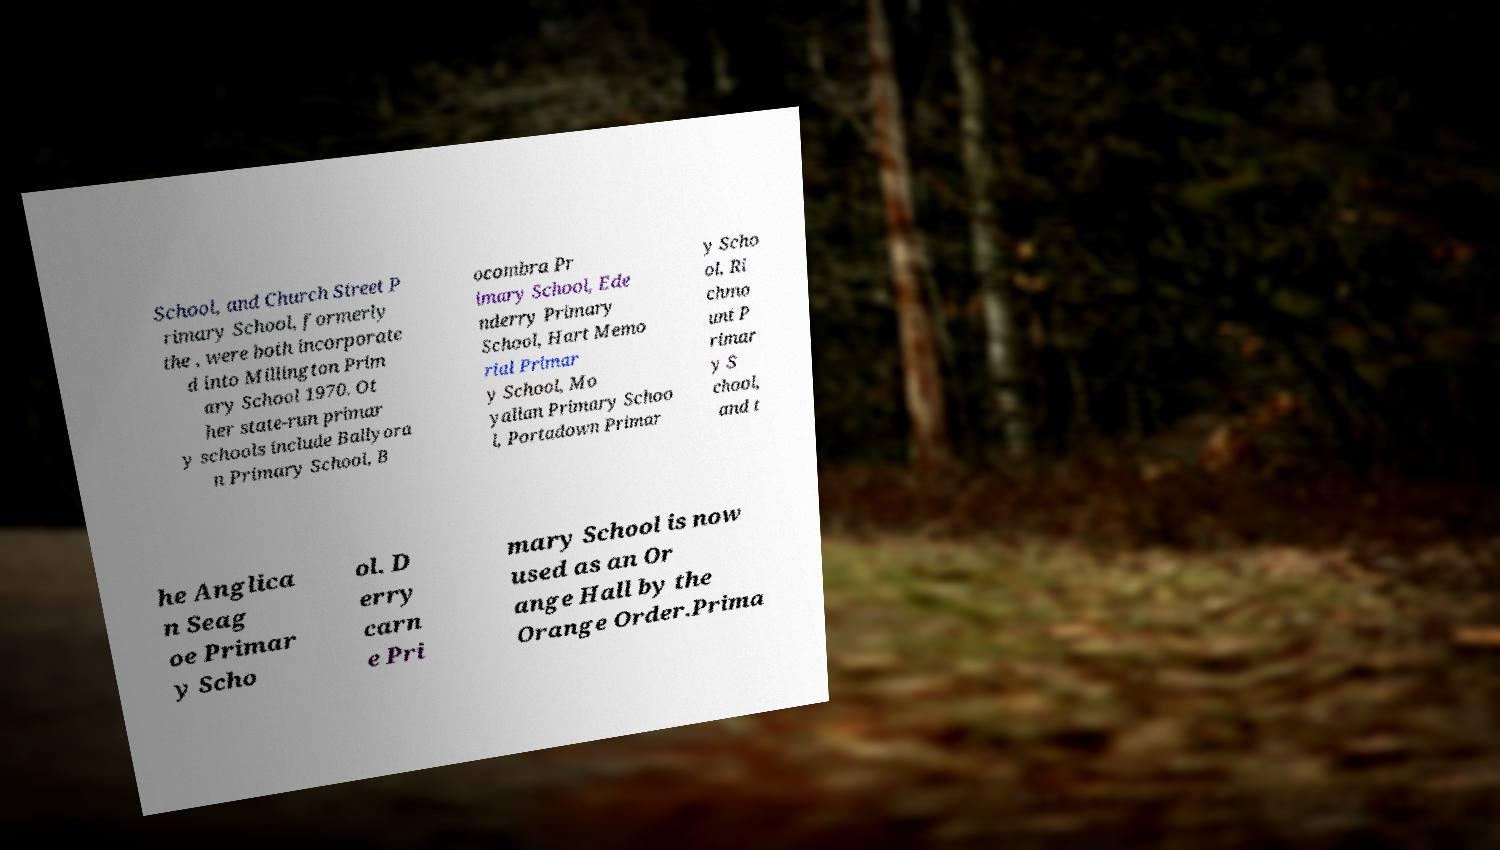Could you assist in decoding the text presented in this image and type it out clearly? School, and Church Street P rimary School, formerly the , were both incorporate d into Millington Prim ary School 1970. Ot her state-run primar y schools include Ballyora n Primary School, B ocombra Pr imary School, Ede nderry Primary School, Hart Memo rial Primar y School, Mo yallan Primary Schoo l, Portadown Primar y Scho ol, Ri chmo unt P rimar y S chool, and t he Anglica n Seag oe Primar y Scho ol. D erry carn e Pri mary School is now used as an Or ange Hall by the Orange Order.Prima 